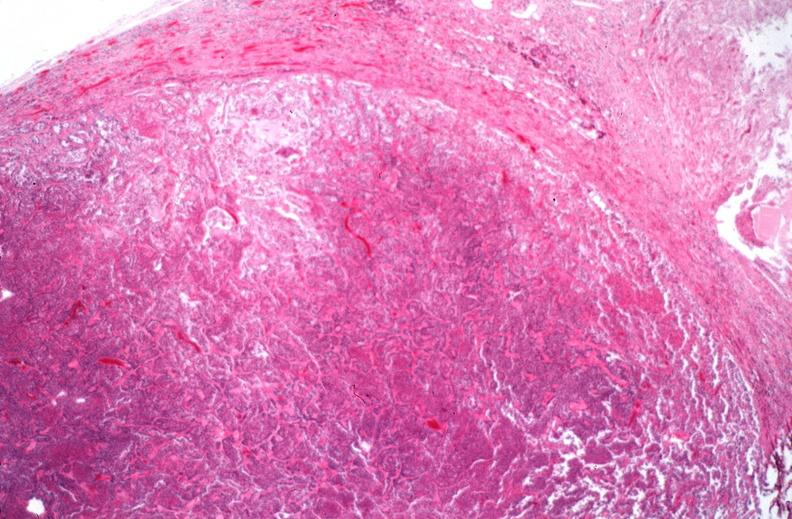where is this part in the figure?
Answer the question using a single word or phrase. Endocrine system 